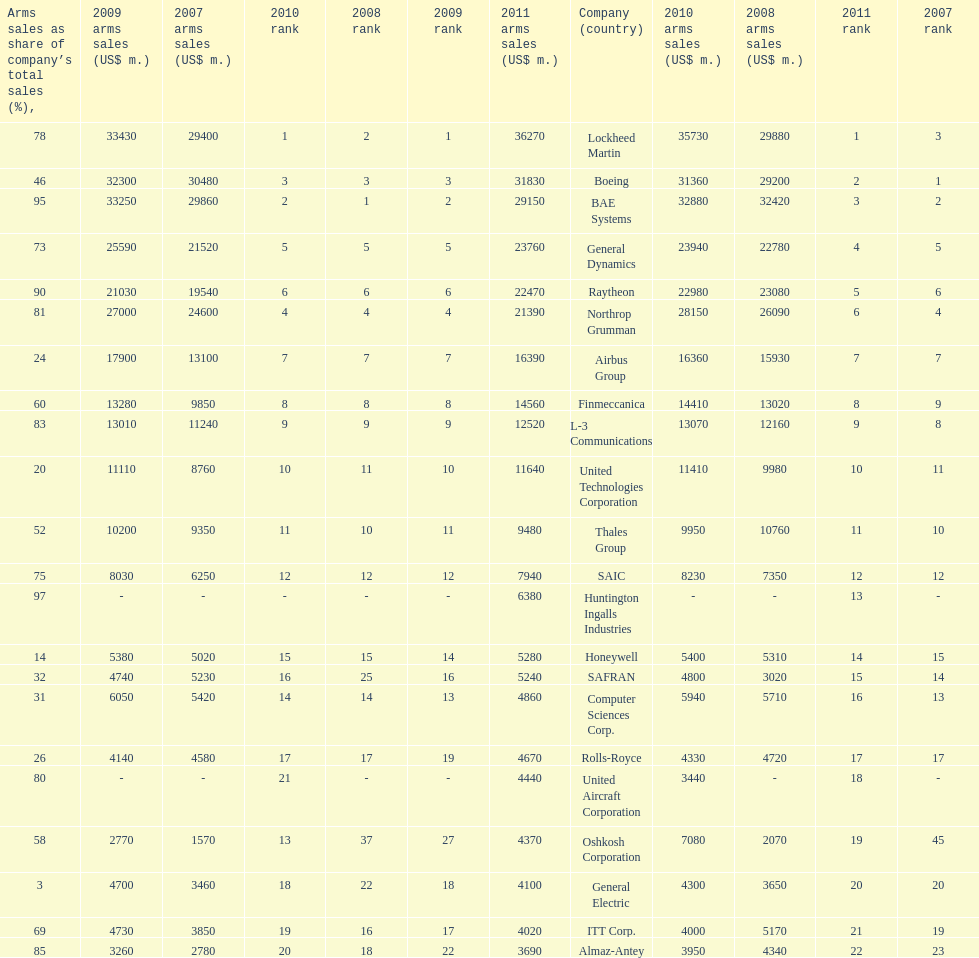What is the difference of the amount sold between boeing and general dynamics in 2007? 8960. Parse the table in full. {'header': ['Arms sales as share of company’s total sales (%),', '2009 arms sales (US$ m.)', '2007 arms sales (US$ m.)', '2010 rank', '2008 rank', '2009 rank', '2011 arms sales (US$ m.)', 'Company (country)', '2010 arms sales (US$ m.)', '2008 arms sales (US$ m.)', '2011 rank', '2007 rank'], 'rows': [['78', '33430', '29400', '1', '2', '1', '36270', 'Lockheed Martin', '35730', '29880', '1', '3'], ['46', '32300', '30480', '3', '3', '3', '31830', 'Boeing', '31360', '29200', '2', '1'], ['95', '33250', '29860', '2', '1', '2', '29150', 'BAE Systems', '32880', '32420', '3', '2'], ['73', '25590', '21520', '5', '5', '5', '23760', 'General Dynamics', '23940', '22780', '4', '5'], ['90', '21030', '19540', '6', '6', '6', '22470', 'Raytheon', '22980', '23080', '5', '6'], ['81', '27000', '24600', '4', '4', '4', '21390', 'Northrop Grumman', '28150', '26090', '6', '4'], ['24', '17900', '13100', '7', '7', '7', '16390', 'Airbus Group', '16360', '15930', '7', '7'], ['60', '13280', '9850', '8', '8', '8', '14560', 'Finmeccanica', '14410', '13020', '8', '9'], ['83', '13010', '11240', '9', '9', '9', '12520', 'L-3 Communications', '13070', '12160', '9', '8'], ['20', '11110', '8760', '10', '11', '10', '11640', 'United Technologies Corporation', '11410', '9980', '10', '11'], ['52', '10200', '9350', '11', '10', '11', '9480', 'Thales Group', '9950', '10760', '11', '10'], ['75', '8030', '6250', '12', '12', '12', '7940', 'SAIC', '8230', '7350', '12', '12'], ['97', '-', '-', '-', '-', '-', '6380', 'Huntington Ingalls Industries', '-', '-', '13', '-'], ['14', '5380', '5020', '15', '15', '14', '5280', 'Honeywell', '5400', '5310', '14', '15'], ['32', '4740', '5230', '16', '25', '16', '5240', 'SAFRAN', '4800', '3020', '15', '14'], ['31', '6050', '5420', '14', '14', '13', '4860', 'Computer Sciences Corp.', '5940', '5710', '16', '13'], ['26', '4140', '4580', '17', '17', '19', '4670', 'Rolls-Royce', '4330', '4720', '17', '17'], ['80', '-', '-', '21', '-', '-', '4440', 'United Aircraft Corporation', '3440', '-', '18', '-'], ['58', '2770', '1570', '13', '37', '27', '4370', 'Oshkosh Corporation', '7080', '2070', '19', '45'], ['3', '4700', '3460', '18', '22', '18', '4100', 'General Electric', '4300', '3650', '20', '20'], ['69', '4730', '3850', '19', '16', '17', '4020', 'ITT Corp.', '4000', '5170', '21', '19'], ['85', '3260', '2780', '20', '18', '22', '3690', 'Almaz-Antey', '3950', '4340', '22', '23']]} 